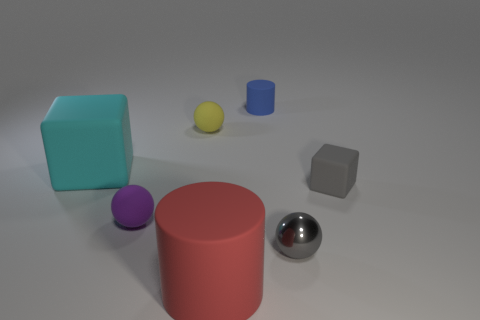There is another matte sphere that is the same size as the purple matte ball; what color is it? The matte sphere of the same size as the purple ball is a soft yellow, complementing the color palette of the scene with its subtle hue. 